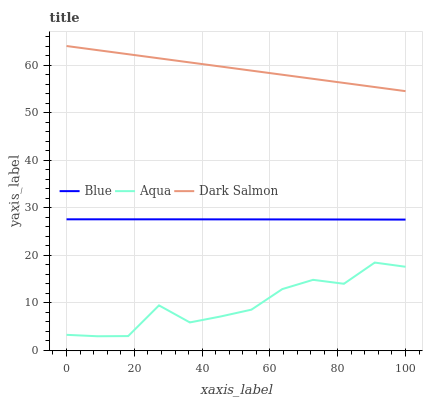Does Aqua have the minimum area under the curve?
Answer yes or no. Yes. Does Dark Salmon have the maximum area under the curve?
Answer yes or no. Yes. Does Dark Salmon have the minimum area under the curve?
Answer yes or no. No. Does Aqua have the maximum area under the curve?
Answer yes or no. No. Is Dark Salmon the smoothest?
Answer yes or no. Yes. Is Aqua the roughest?
Answer yes or no. Yes. Is Aqua the smoothest?
Answer yes or no. No. Is Dark Salmon the roughest?
Answer yes or no. No. Does Dark Salmon have the lowest value?
Answer yes or no. No. Does Dark Salmon have the highest value?
Answer yes or no. Yes. Does Aqua have the highest value?
Answer yes or no. No. Is Aqua less than Dark Salmon?
Answer yes or no. Yes. Is Dark Salmon greater than Blue?
Answer yes or no. Yes. Does Aqua intersect Dark Salmon?
Answer yes or no. No. 